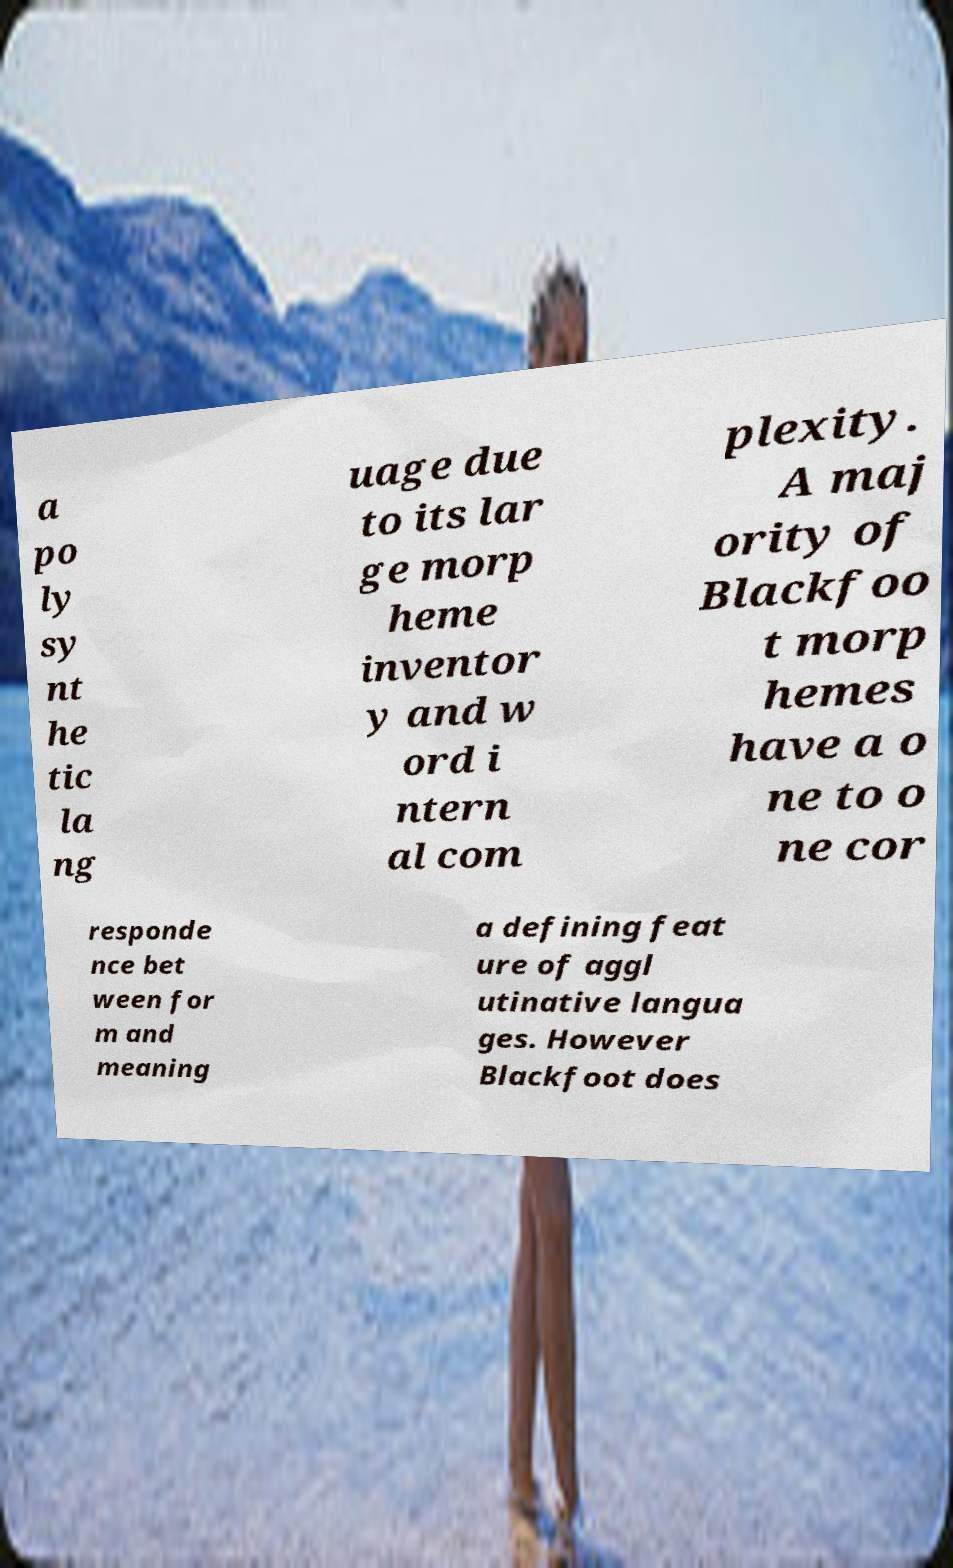Could you extract and type out the text from this image? a po ly sy nt he tic la ng uage due to its lar ge morp heme inventor y and w ord i ntern al com plexity. A maj ority of Blackfoo t morp hemes have a o ne to o ne cor responde nce bet ween for m and meaning a defining feat ure of aggl utinative langua ges. However Blackfoot does 